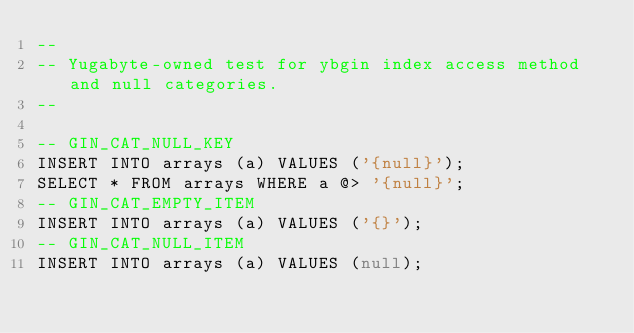Convert code to text. <code><loc_0><loc_0><loc_500><loc_500><_SQL_>--
-- Yugabyte-owned test for ybgin index access method and null categories.
--

-- GIN_CAT_NULL_KEY
INSERT INTO arrays (a) VALUES ('{null}');
SELECT * FROM arrays WHERE a @> '{null}';
-- GIN_CAT_EMPTY_ITEM
INSERT INTO arrays (a) VALUES ('{}');
-- GIN_CAT_NULL_ITEM
INSERT INTO arrays (a) VALUES (null);
</code> 